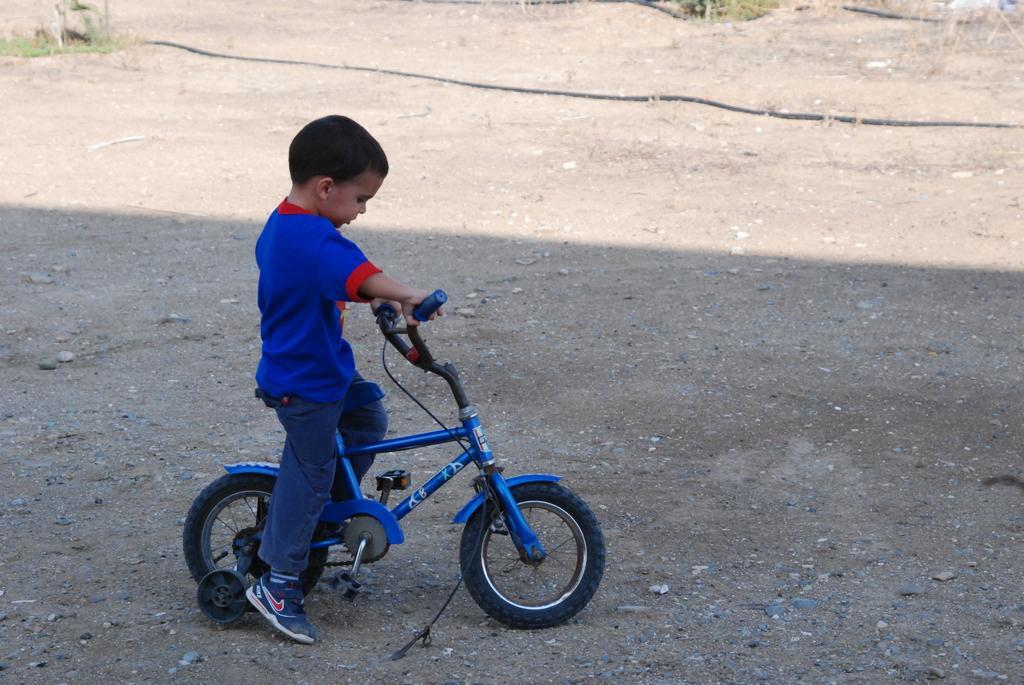Describe this image in one or two sentences. This picture is clicked outside the room. Here, the boy in blue t-shirt and blue jeans is riding bicycle. On the bottom of the picture, we see pipe and beside that, we see grass. 